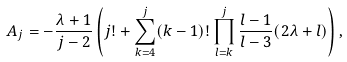Convert formula to latex. <formula><loc_0><loc_0><loc_500><loc_500>A _ { j } = - \frac { \lambda + 1 } { j - 2 } \left ( j ! + \sum _ { k = 4 } ^ { j } ( k - 1 ) ! \prod _ { l = k } ^ { j } \frac { l - 1 } { l - 3 } ( 2 \lambda + l ) \right ) ,</formula> 